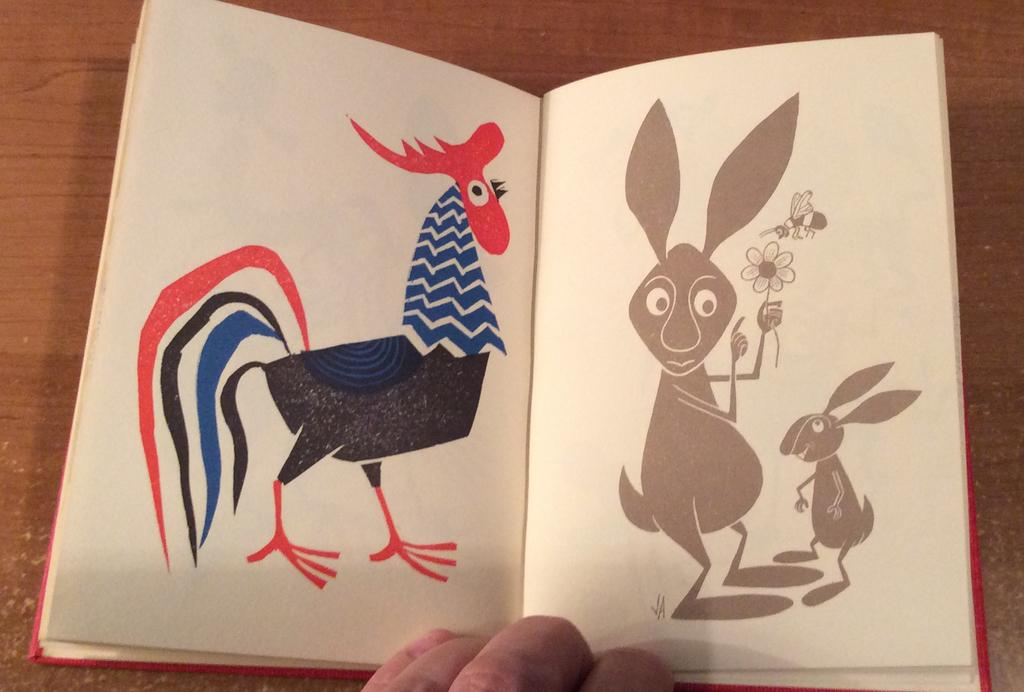What body part is visible in the image? There is a person's hand in the image. What object is associated with the hand in the image? There is a book in the image. What type of surface is the book and hand resting on? The wooden surface is present in the image. What type of cherries are being used to hold the book open in the image? There are no cherries present in the image; the book is not being held open by any fruit. 